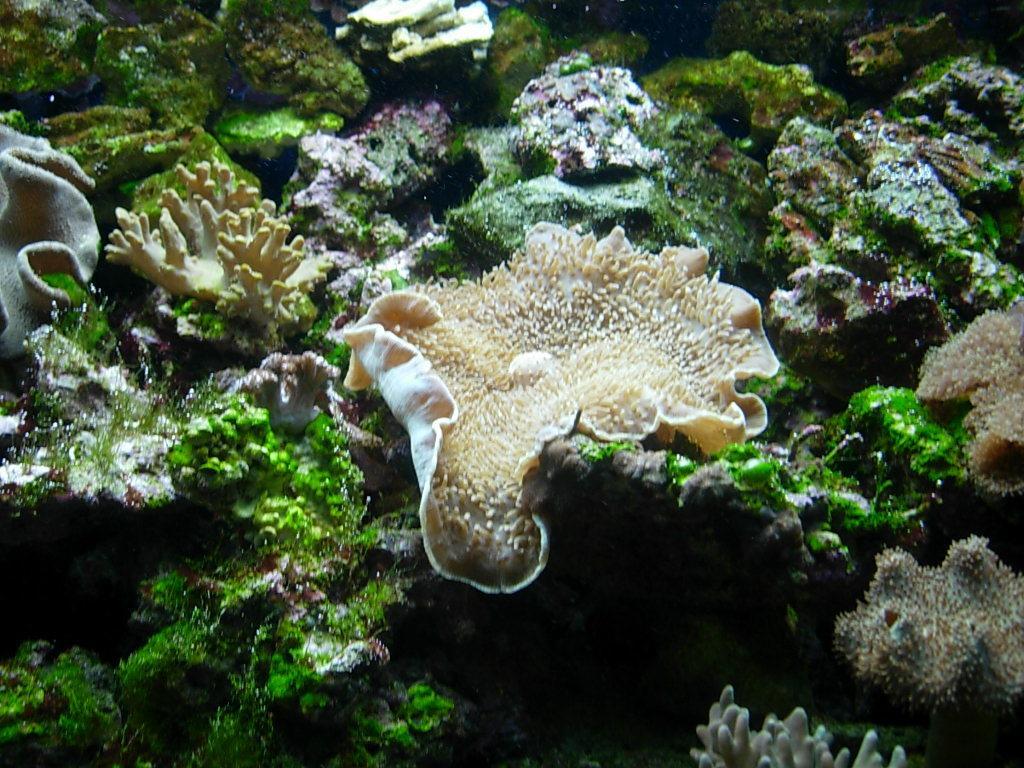In one or two sentences, can you explain what this image depicts? In the foreground of this picture, there are few water plants under the water. 